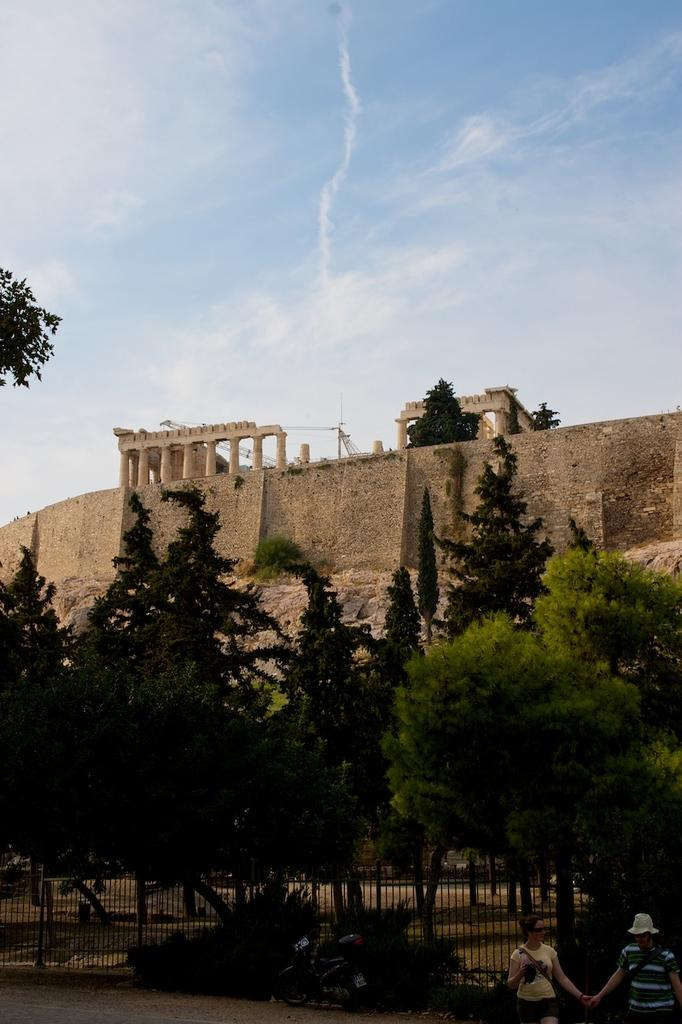What can be seen in the front of the image? There are persons in the front of the image. What is located in the center of the image? There are trees in the center of the image. What type of barrier is present in the image? There is a fence in the image. What structure can be seen in the background of the image? There is a fort in the background of the image. How would you describe the sky in the image? The sky is cloudy in the image. What type of cap is the mom wearing in the image? There is no mom or cap present in the image. What type of harmony is being played by the persons in the image? There is no indication of any music or harmony being played in the image. 